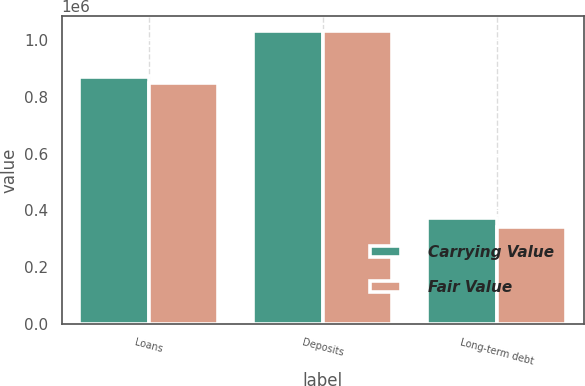Convert chart to OTSL. <chart><loc_0><loc_0><loc_500><loc_500><stacked_bar_chart><ecel><fcel>Loans<fcel>Deposits<fcel>Long-term debt<nl><fcel>Carrying Value<fcel>870520<fcel>1.03304e+06<fcel>372265<nl><fcel>Fair Value<fcel>849685<fcel>1.03325e+06<fcel>343211<nl></chart> 